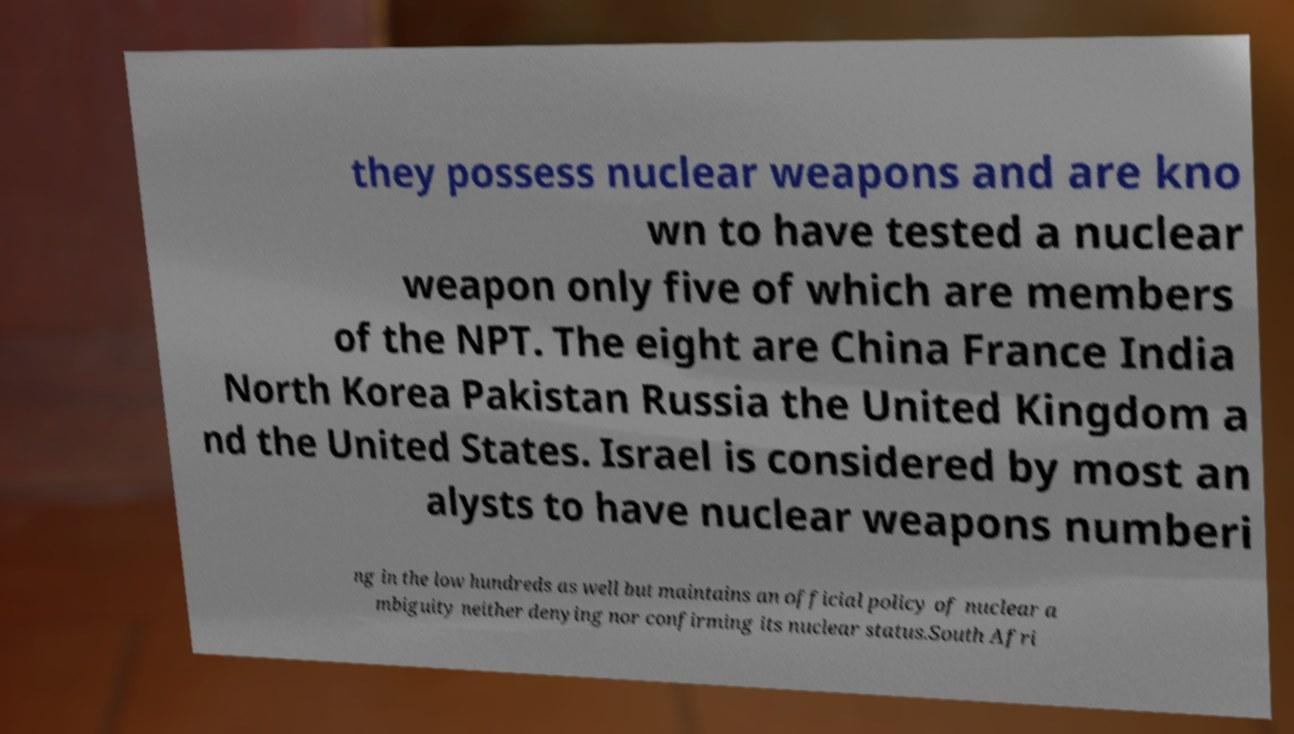Please read and relay the text visible in this image. What does it say? they possess nuclear weapons and are kno wn to have tested a nuclear weapon only five of which are members of the NPT. The eight are China France India North Korea Pakistan Russia the United Kingdom a nd the United States. Israel is considered by most an alysts to have nuclear weapons numberi ng in the low hundreds as well but maintains an official policy of nuclear a mbiguity neither denying nor confirming its nuclear status.South Afri 